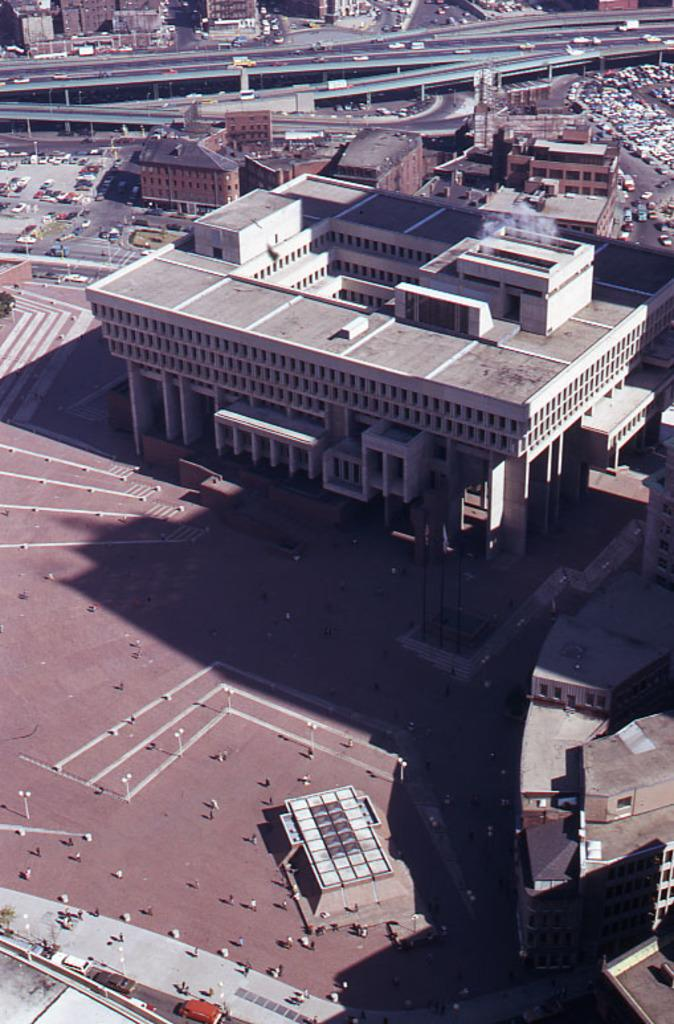What type of structures can be seen in the image? There are buildings in the image. What else is present in the image besides buildings? There are vehicles and persons visible in the image. What are the poles likely used for in the image? The poles in the image are likely used for supporting wires or other infrastructure. What type of appliance can be seen in the image? There is no appliance present in the image. What type of army is visible in the image? There is no army present in the image. How many screws can be seen in the image? There are no screws visible in the image. 